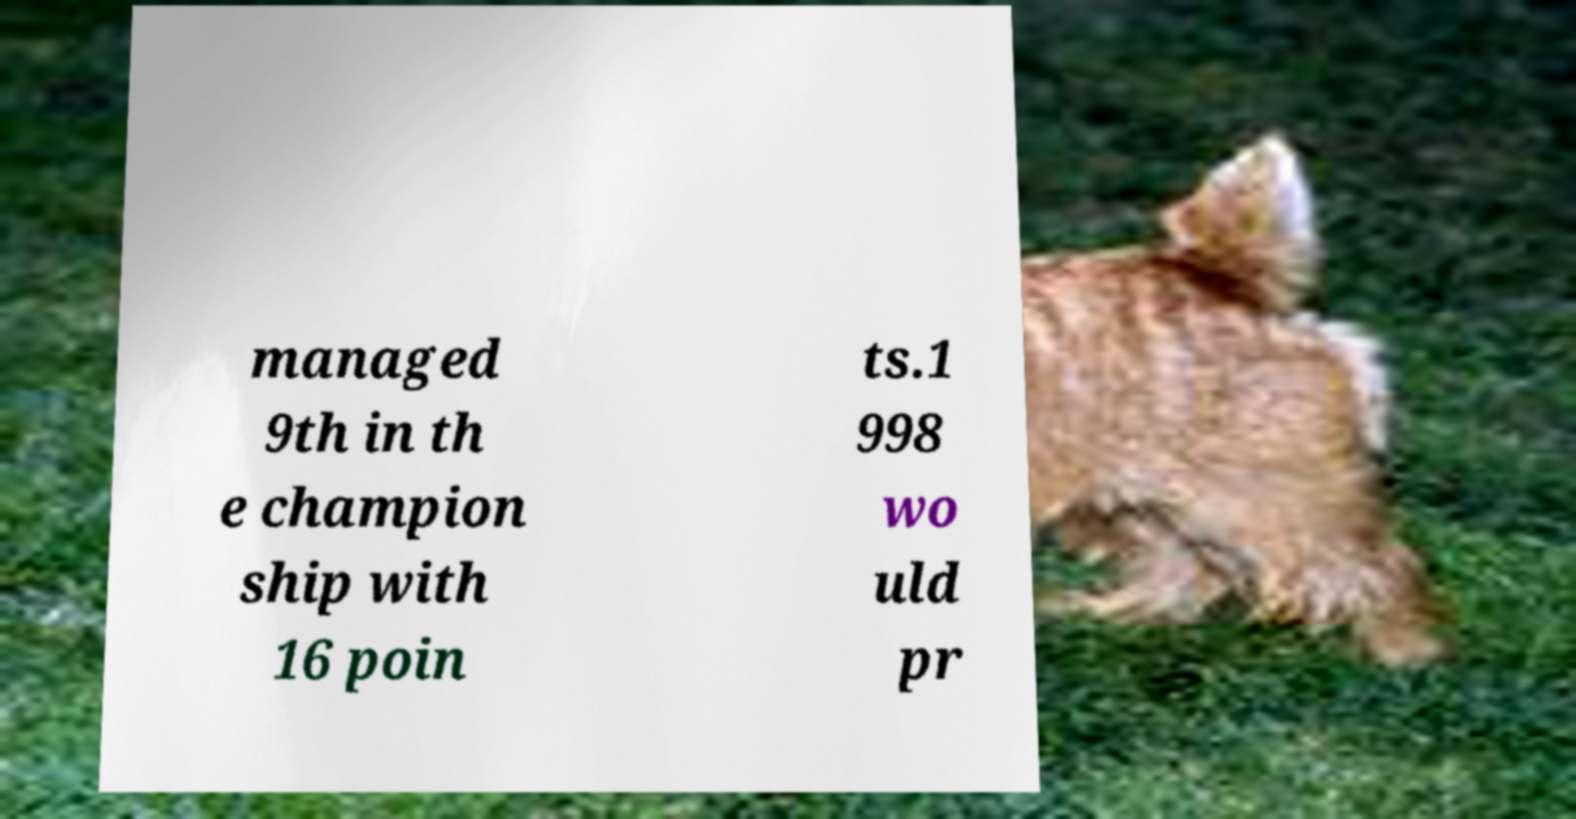Can you read and provide the text displayed in the image?This photo seems to have some interesting text. Can you extract and type it out for me? managed 9th in th e champion ship with 16 poin ts.1 998 wo uld pr 